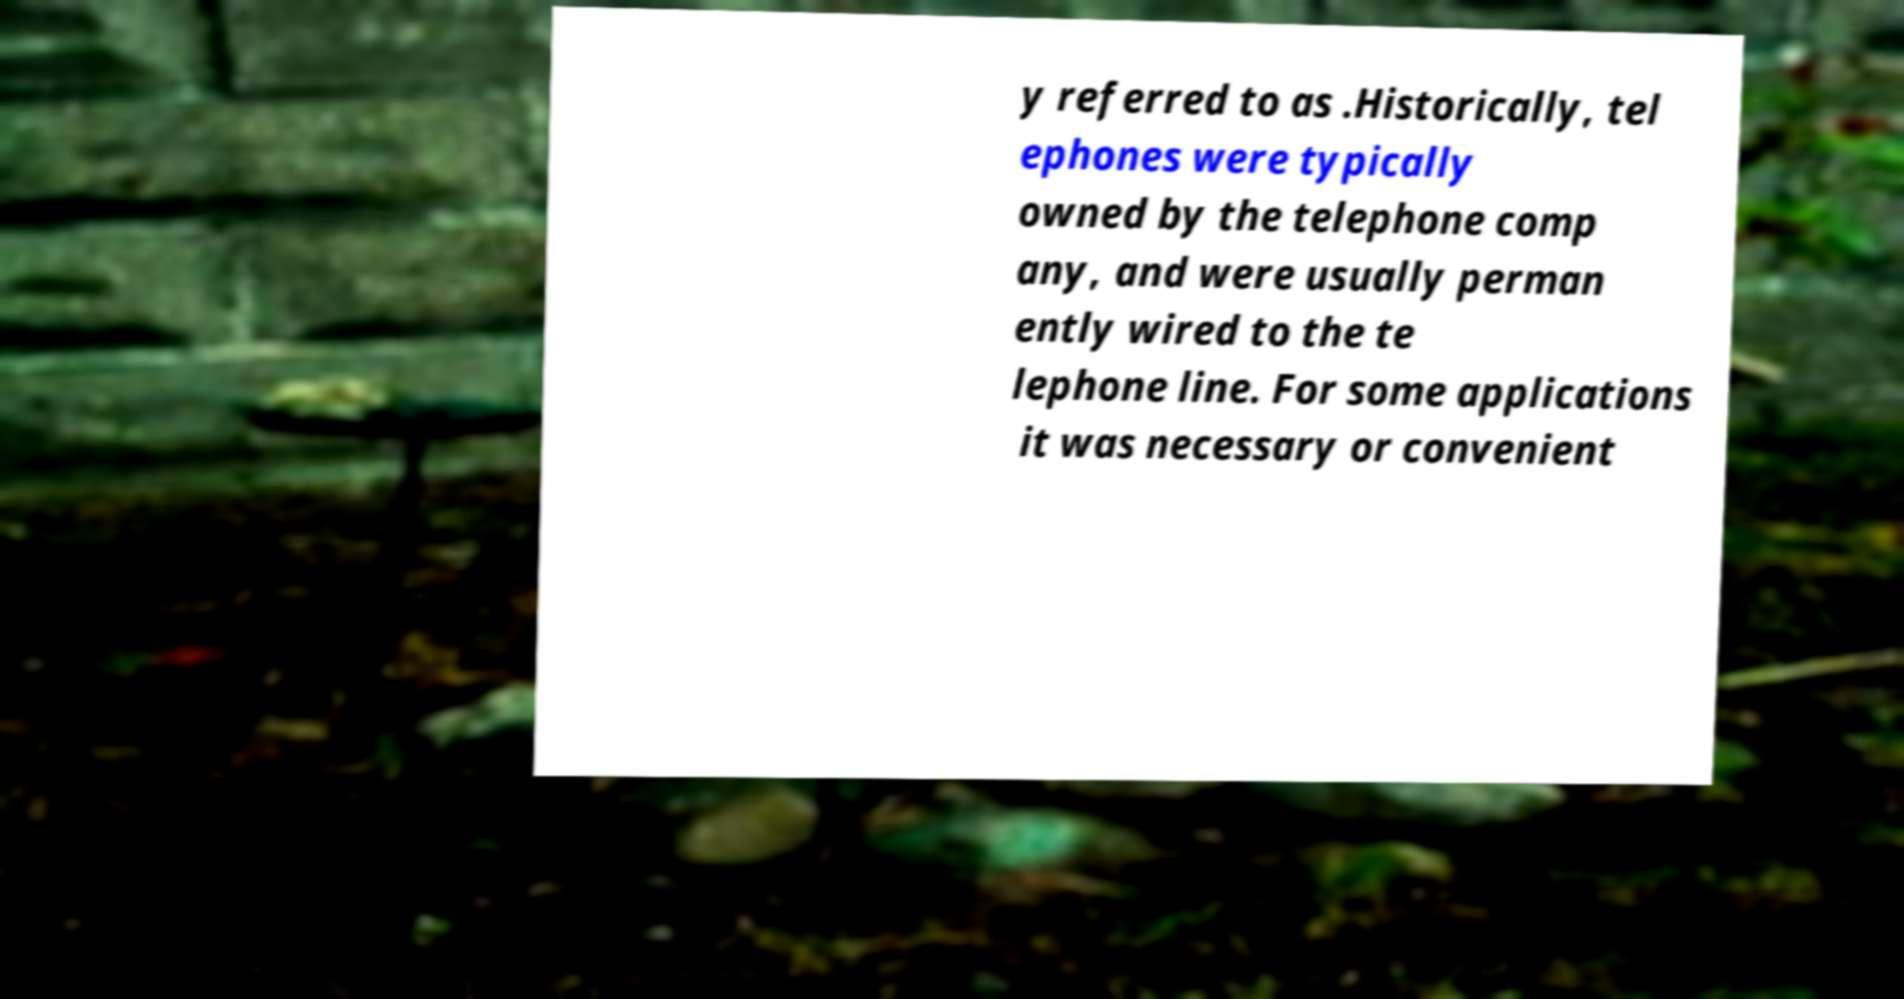What messages or text are displayed in this image? I need them in a readable, typed format. y referred to as .Historically, tel ephones were typically owned by the telephone comp any, and were usually perman ently wired to the te lephone line. For some applications it was necessary or convenient 